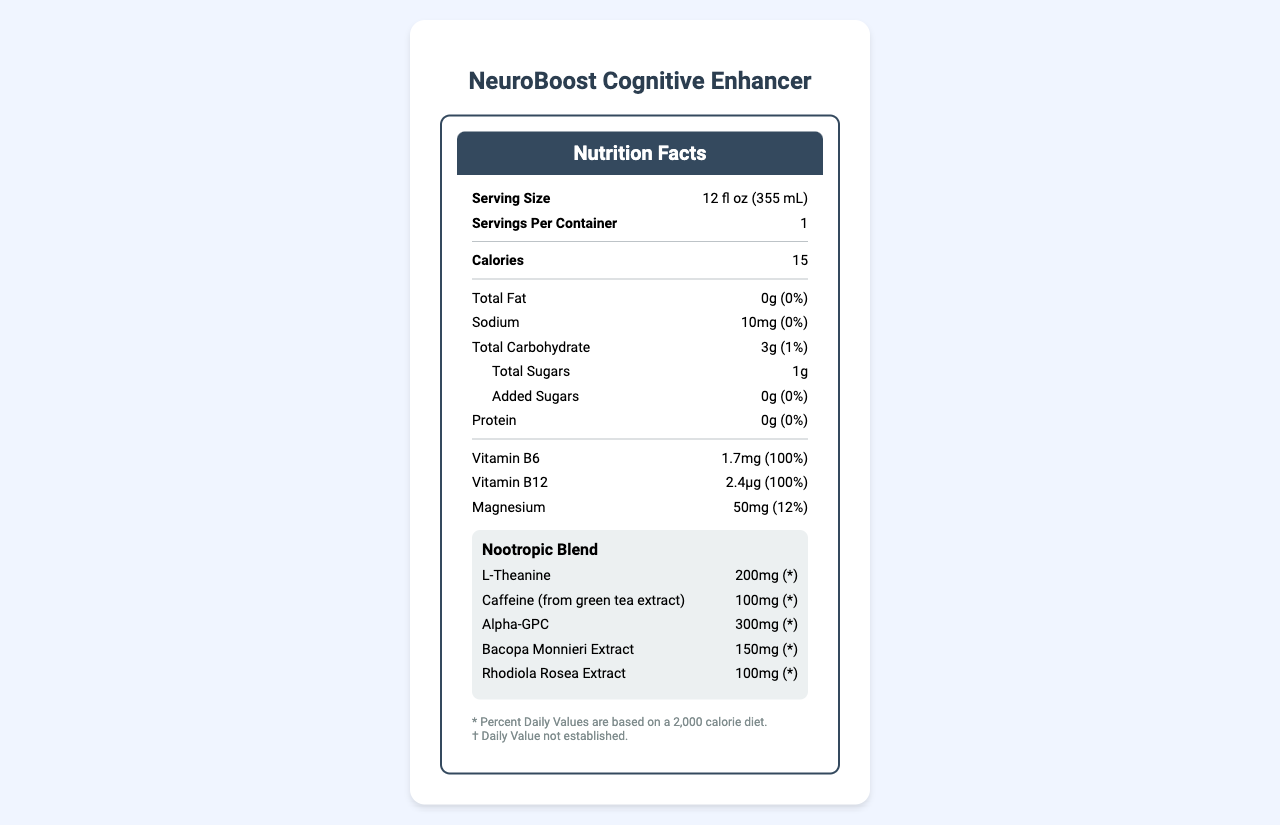what is the serving size? The serving size is listed as "12 fl oz (355 mL)" at the top of the document.
Answer: 12 fl oz (355 mL) how many calories are in one serving? The calories per serving are listed as 15 in the "Calories" section.
Answer: 15 how much sodium does one serving contain? The sodium content is listed as "10mg" with a daily value of 0%.
Answer: 10mg what is the percentage of daily value for magnesium? The daily value for magnesium is listed as 12% next to its amount.
Answer: 12% what vitamins are included? The vitamins included are listed as "Vitamin B6" with 100% daily value and "Vitamin B12" with 100% daily value.
Answer: Vitamin B6 and Vitamin B12 which nootropic has the highest amount per serving? A. L-Theanine B. Caffeine C. Alpha-GPC D. Bacopa Monnieri Extract Alpha-GPC has the highest amount per serving at 300mg, compared to L-Theanine (200mg), Caffeine (100mg), and Bacopa Monnieri Extract (150mg).
Answer: C what is the daily value of protein in this beverage? A. 0% B. 1% C. 5% D. 10% The daily value of protein is listed as 0%.
Answer: A is there any added sugar in the beverage? The document lists "Added Sugars" as 0g with a 0% daily value.
Answer: No does the beverage contain any allergens? The allergen information states that it is manufactured in a facility that also processes soy and tree nuts.
Answer: Yes summarize the main features of the NeuroBoost Cognitive Enhancer nutrition label. The nutrition label highlights the key nutritional elements, vitamins, and nootropics in the beverage, along with allergen information and a disclaimer about the daily values.
Answer: The NeuroBoost Cognitive Enhancer is a functional beverage with a low-calorie count (15 calories per serving). It contains no fat, minimal sodium (10mg), low carbohydrates (3g), and almost no sugars (1g with 0g added sugars). It includes vitamins B6 and B12, magnesium, and a blend of nootropics such as L-Theanine, Caffeine, Alpha-GPC, Bacopa Monnieri Extract, and Rhodiola Rosea Extract. how much sugar is contained in a serving? The total sugars per serving are listed as 1g.
Answer: 1g what is the primary purpose of the disclaimer at the bottom of the document? The disclaimer mentions that the Percent Daily Values are based on a 2,000 calorie diet and that daily values for the nootropic ingredients are not established. It also states that the product has not been evaluated by the FDA for diagnosing, treating, curing, or preventing any disease.
Answer: To inform that the daily values for nootropics are not established and that the product's statements have not been evaluated by the FDA. what is the combined amount of L-Theanine and Caffeine per serving? L-Theanine is 200mg, and Caffeine is 100mg. Combined, they total 300mg per serving.
Answer: 300mg how many servings are in each container of NeuroBoost Cognitive Enhancer? The document states that there is 1 serving per container.
Answer: 1 what is the flavor of the NeuroBoost Cognitive Enhancer? The document does not provide specific information about the flavor of the beverage.
Answer: Not enough information 